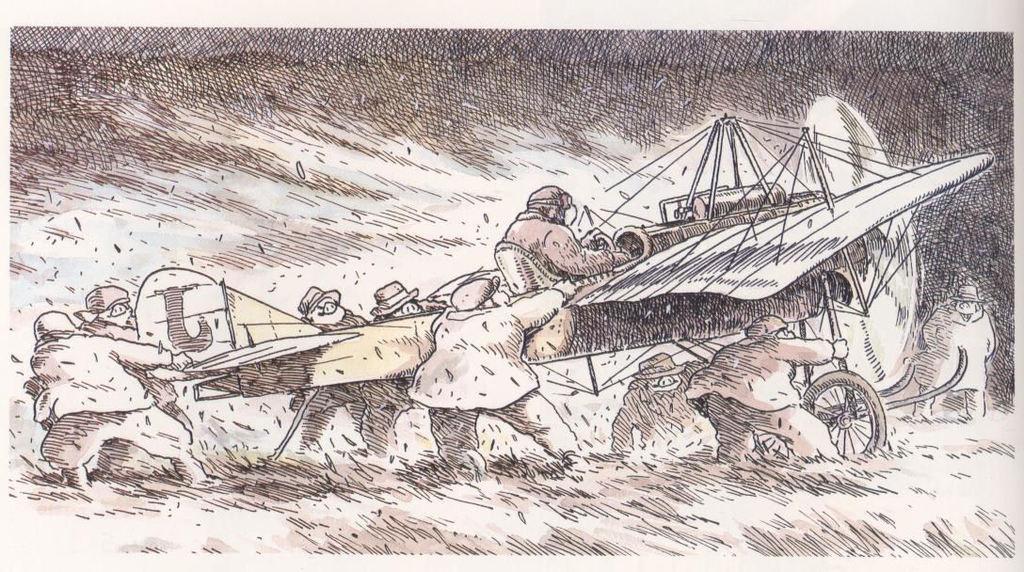Can you describe this image briefly? In this image there is a sketch of few people holding airplane. On the airplane there is a person sitting. 